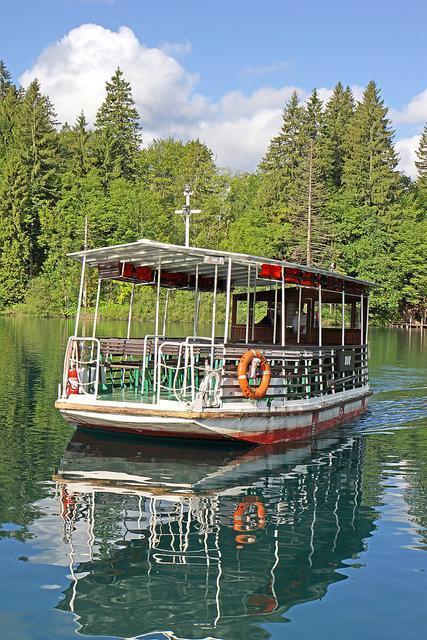How many people are there?
Give a very brief answer. 1. 